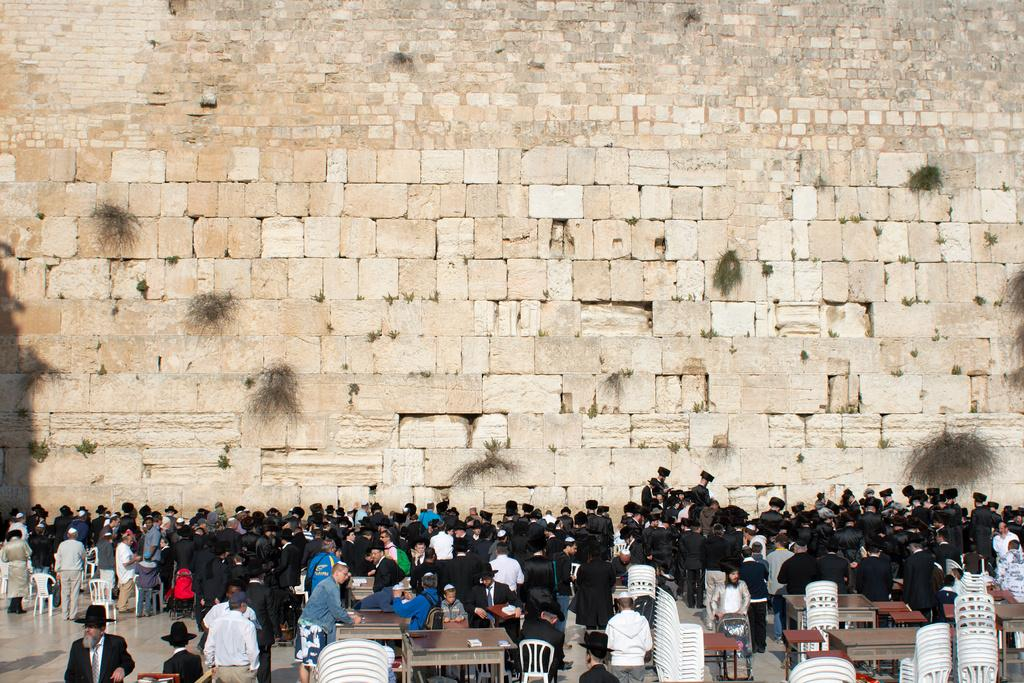How many people are in the image? There is a group of people in the image, but the exact number cannot be determined from the provided facts. What type of furniture is present in the image? There are chairs and tables in the image. What type of structure can be seen in the background of the image? There is a brick wall in the image. What is the answer to the riddle written on the wrist of the person in the image? There is no mention of a riddle or a person's wrist in the provided facts, so we cannot answer this question. What type of property is owned by the person in the image? There is no information about the person's property in the image, so we cannot answer this question. 